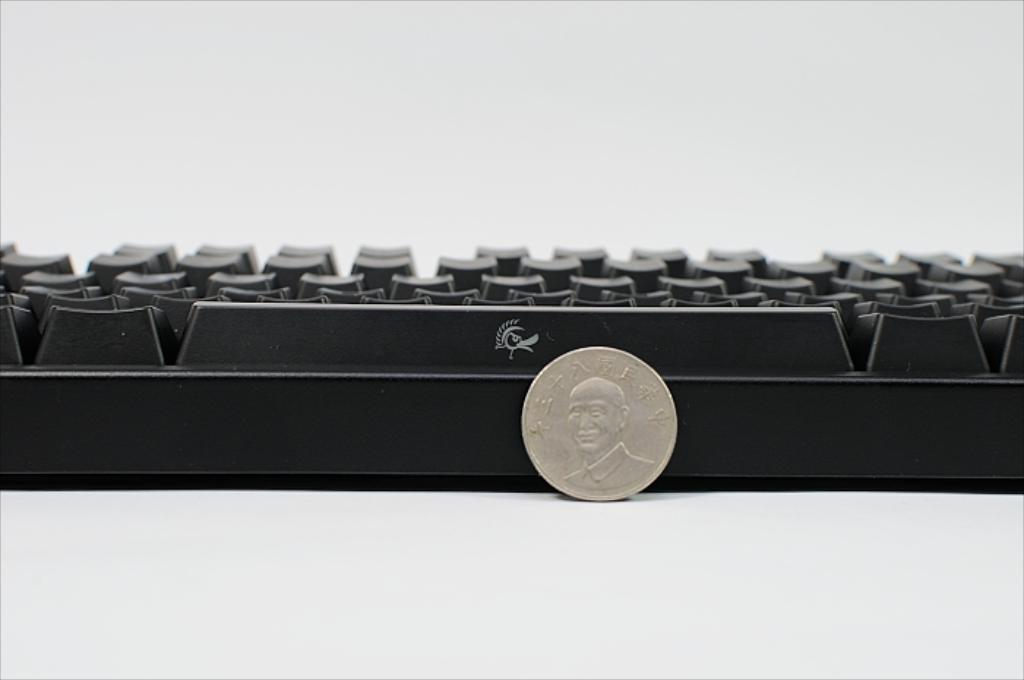How would you summarize this image in a sentence or two? In this image I can see the coin and I can also see the keyboard and the background is in white color. 